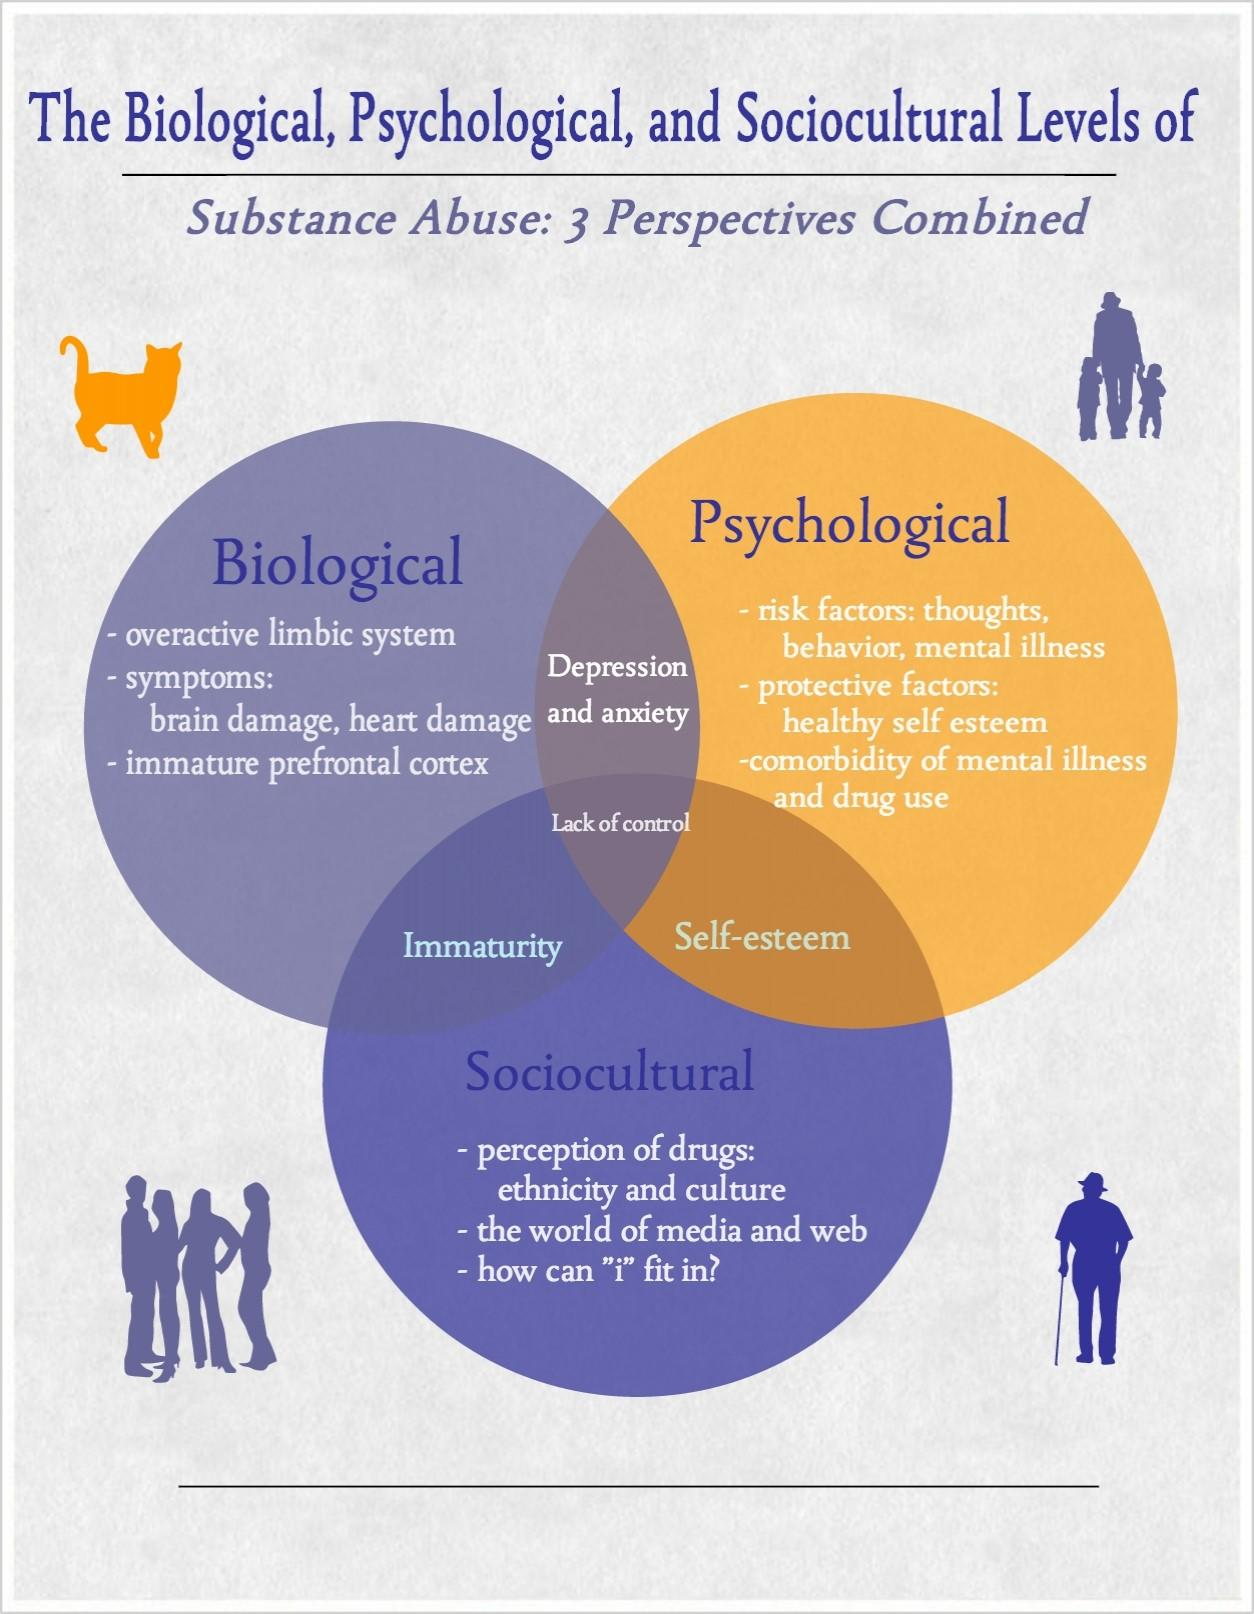Highlight a few significant elements in this photo. Depression and anxiety are the primary causes of substance abuse due to the intersection of biological and psychological factors. According to sociocultural and biological perspectives, the cause of substance abuse is immaturity. According to sociocultural and psychological perspectives, substance abuse is often caused by low self-esteem. The main cause of substance abuse from a biological, sociocultural, and psychological perspective is a lack of control. 